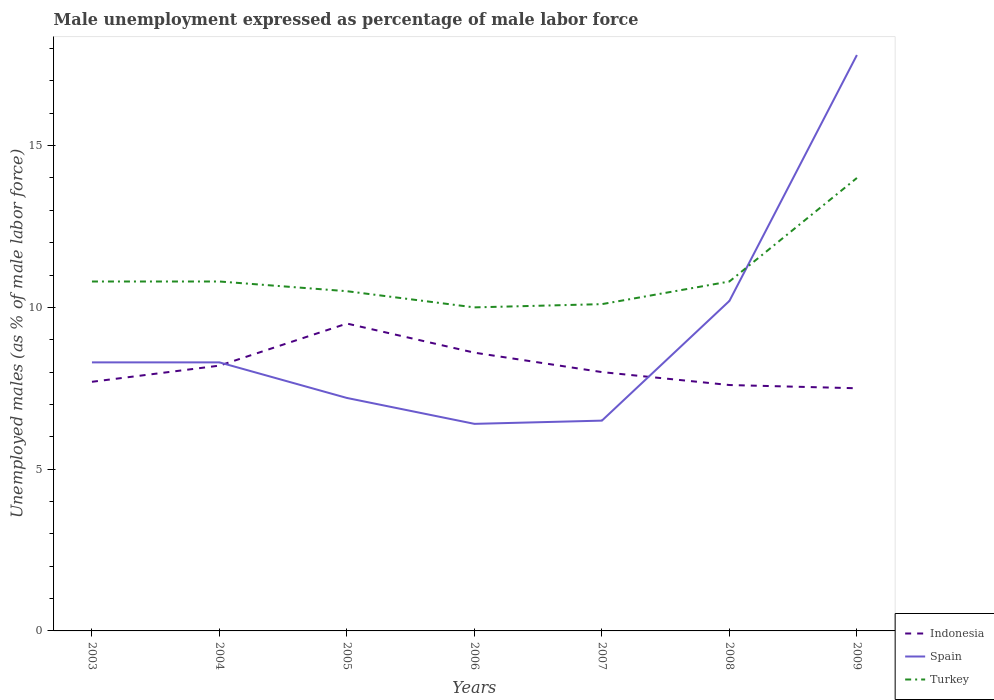How many different coloured lines are there?
Provide a succinct answer. 3. In which year was the unemployment in males in in Turkey maximum?
Keep it short and to the point. 2006. What is the total unemployment in males in in Spain in the graph?
Provide a short and direct response. 1.9. What is the difference between the highest and the lowest unemployment in males in in Spain?
Your answer should be compact. 2. Is the unemployment in males in in Turkey strictly greater than the unemployment in males in in Spain over the years?
Offer a terse response. No. How many lines are there?
Your answer should be compact. 3. What is the title of the graph?
Provide a short and direct response. Male unemployment expressed as percentage of male labor force. Does "Palau" appear as one of the legend labels in the graph?
Give a very brief answer. No. What is the label or title of the X-axis?
Give a very brief answer. Years. What is the label or title of the Y-axis?
Your answer should be very brief. Unemployed males (as % of male labor force). What is the Unemployed males (as % of male labor force) in Indonesia in 2003?
Make the answer very short. 7.7. What is the Unemployed males (as % of male labor force) of Spain in 2003?
Offer a terse response. 8.3. What is the Unemployed males (as % of male labor force) in Turkey in 2003?
Give a very brief answer. 10.8. What is the Unemployed males (as % of male labor force) of Indonesia in 2004?
Provide a short and direct response. 8.2. What is the Unemployed males (as % of male labor force) of Spain in 2004?
Offer a very short reply. 8.3. What is the Unemployed males (as % of male labor force) of Turkey in 2004?
Your answer should be compact. 10.8. What is the Unemployed males (as % of male labor force) in Indonesia in 2005?
Make the answer very short. 9.5. What is the Unemployed males (as % of male labor force) in Spain in 2005?
Give a very brief answer. 7.2. What is the Unemployed males (as % of male labor force) in Turkey in 2005?
Give a very brief answer. 10.5. What is the Unemployed males (as % of male labor force) of Indonesia in 2006?
Your answer should be compact. 8.6. What is the Unemployed males (as % of male labor force) in Spain in 2006?
Provide a succinct answer. 6.4. What is the Unemployed males (as % of male labor force) in Turkey in 2007?
Give a very brief answer. 10.1. What is the Unemployed males (as % of male labor force) in Indonesia in 2008?
Provide a succinct answer. 7.6. What is the Unemployed males (as % of male labor force) of Spain in 2008?
Your answer should be very brief. 10.2. What is the Unemployed males (as % of male labor force) in Turkey in 2008?
Provide a short and direct response. 10.8. What is the Unemployed males (as % of male labor force) in Indonesia in 2009?
Provide a succinct answer. 7.5. What is the Unemployed males (as % of male labor force) of Spain in 2009?
Your response must be concise. 17.8. Across all years, what is the maximum Unemployed males (as % of male labor force) in Indonesia?
Your answer should be very brief. 9.5. Across all years, what is the maximum Unemployed males (as % of male labor force) of Spain?
Give a very brief answer. 17.8. Across all years, what is the minimum Unemployed males (as % of male labor force) of Spain?
Keep it short and to the point. 6.4. What is the total Unemployed males (as % of male labor force) of Indonesia in the graph?
Provide a succinct answer. 57.1. What is the total Unemployed males (as % of male labor force) of Spain in the graph?
Your answer should be very brief. 64.7. What is the difference between the Unemployed males (as % of male labor force) in Spain in 2003 and that in 2004?
Provide a short and direct response. 0. What is the difference between the Unemployed males (as % of male labor force) of Spain in 2003 and that in 2005?
Provide a short and direct response. 1.1. What is the difference between the Unemployed males (as % of male labor force) in Turkey in 2003 and that in 2005?
Offer a very short reply. 0.3. What is the difference between the Unemployed males (as % of male labor force) of Spain in 2003 and that in 2006?
Ensure brevity in your answer.  1.9. What is the difference between the Unemployed males (as % of male labor force) in Turkey in 2003 and that in 2006?
Provide a succinct answer. 0.8. What is the difference between the Unemployed males (as % of male labor force) in Indonesia in 2003 and that in 2007?
Offer a very short reply. -0.3. What is the difference between the Unemployed males (as % of male labor force) of Indonesia in 2003 and that in 2008?
Your response must be concise. 0.1. What is the difference between the Unemployed males (as % of male labor force) of Indonesia in 2003 and that in 2009?
Your answer should be very brief. 0.2. What is the difference between the Unemployed males (as % of male labor force) in Turkey in 2003 and that in 2009?
Provide a succinct answer. -3.2. What is the difference between the Unemployed males (as % of male labor force) of Spain in 2004 and that in 2005?
Offer a terse response. 1.1. What is the difference between the Unemployed males (as % of male labor force) in Turkey in 2004 and that in 2005?
Ensure brevity in your answer.  0.3. What is the difference between the Unemployed males (as % of male labor force) of Spain in 2004 and that in 2006?
Ensure brevity in your answer.  1.9. What is the difference between the Unemployed males (as % of male labor force) in Indonesia in 2004 and that in 2007?
Your answer should be compact. 0.2. What is the difference between the Unemployed males (as % of male labor force) in Turkey in 2004 and that in 2007?
Give a very brief answer. 0.7. What is the difference between the Unemployed males (as % of male labor force) in Indonesia in 2004 and that in 2008?
Your answer should be very brief. 0.6. What is the difference between the Unemployed males (as % of male labor force) in Spain in 2004 and that in 2009?
Give a very brief answer. -9.5. What is the difference between the Unemployed males (as % of male labor force) of Indonesia in 2005 and that in 2006?
Your response must be concise. 0.9. What is the difference between the Unemployed males (as % of male labor force) in Spain in 2005 and that in 2006?
Your response must be concise. 0.8. What is the difference between the Unemployed males (as % of male labor force) in Turkey in 2005 and that in 2006?
Your answer should be compact. 0.5. What is the difference between the Unemployed males (as % of male labor force) in Spain in 2005 and that in 2007?
Provide a short and direct response. 0.7. What is the difference between the Unemployed males (as % of male labor force) of Spain in 2005 and that in 2008?
Your answer should be very brief. -3. What is the difference between the Unemployed males (as % of male labor force) of Turkey in 2005 and that in 2008?
Your response must be concise. -0.3. What is the difference between the Unemployed males (as % of male labor force) in Indonesia in 2005 and that in 2009?
Make the answer very short. 2. What is the difference between the Unemployed males (as % of male labor force) of Turkey in 2005 and that in 2009?
Provide a succinct answer. -3.5. What is the difference between the Unemployed males (as % of male labor force) in Spain in 2006 and that in 2007?
Keep it short and to the point. -0.1. What is the difference between the Unemployed males (as % of male labor force) of Turkey in 2006 and that in 2007?
Offer a very short reply. -0.1. What is the difference between the Unemployed males (as % of male labor force) in Indonesia in 2007 and that in 2008?
Your answer should be very brief. 0.4. What is the difference between the Unemployed males (as % of male labor force) of Spain in 2007 and that in 2008?
Offer a terse response. -3.7. What is the difference between the Unemployed males (as % of male labor force) in Indonesia in 2007 and that in 2009?
Ensure brevity in your answer.  0.5. What is the difference between the Unemployed males (as % of male labor force) of Spain in 2007 and that in 2009?
Your answer should be very brief. -11.3. What is the difference between the Unemployed males (as % of male labor force) in Turkey in 2007 and that in 2009?
Make the answer very short. -3.9. What is the difference between the Unemployed males (as % of male labor force) in Indonesia in 2008 and that in 2009?
Your response must be concise. 0.1. What is the difference between the Unemployed males (as % of male labor force) in Turkey in 2008 and that in 2009?
Give a very brief answer. -3.2. What is the difference between the Unemployed males (as % of male labor force) in Indonesia in 2003 and the Unemployed males (as % of male labor force) in Turkey in 2004?
Offer a terse response. -3.1. What is the difference between the Unemployed males (as % of male labor force) in Spain in 2003 and the Unemployed males (as % of male labor force) in Turkey in 2004?
Give a very brief answer. -2.5. What is the difference between the Unemployed males (as % of male labor force) of Indonesia in 2003 and the Unemployed males (as % of male labor force) of Spain in 2005?
Your answer should be very brief. 0.5. What is the difference between the Unemployed males (as % of male labor force) in Indonesia in 2003 and the Unemployed males (as % of male labor force) in Turkey in 2005?
Provide a short and direct response. -2.8. What is the difference between the Unemployed males (as % of male labor force) of Indonesia in 2003 and the Unemployed males (as % of male labor force) of Spain in 2006?
Offer a very short reply. 1.3. What is the difference between the Unemployed males (as % of male labor force) in Indonesia in 2003 and the Unemployed males (as % of male labor force) in Spain in 2007?
Offer a very short reply. 1.2. What is the difference between the Unemployed males (as % of male labor force) in Indonesia in 2003 and the Unemployed males (as % of male labor force) in Spain in 2008?
Offer a very short reply. -2.5. What is the difference between the Unemployed males (as % of male labor force) in Indonesia in 2003 and the Unemployed males (as % of male labor force) in Spain in 2009?
Your response must be concise. -10.1. What is the difference between the Unemployed males (as % of male labor force) of Indonesia in 2003 and the Unemployed males (as % of male labor force) of Turkey in 2009?
Provide a succinct answer. -6.3. What is the difference between the Unemployed males (as % of male labor force) of Indonesia in 2004 and the Unemployed males (as % of male labor force) of Spain in 2005?
Give a very brief answer. 1. What is the difference between the Unemployed males (as % of male labor force) in Indonesia in 2004 and the Unemployed males (as % of male labor force) in Turkey in 2005?
Provide a succinct answer. -2.3. What is the difference between the Unemployed males (as % of male labor force) in Indonesia in 2004 and the Unemployed males (as % of male labor force) in Spain in 2006?
Keep it short and to the point. 1.8. What is the difference between the Unemployed males (as % of male labor force) in Indonesia in 2004 and the Unemployed males (as % of male labor force) in Turkey in 2006?
Offer a very short reply. -1.8. What is the difference between the Unemployed males (as % of male labor force) in Spain in 2004 and the Unemployed males (as % of male labor force) in Turkey in 2006?
Your answer should be compact. -1.7. What is the difference between the Unemployed males (as % of male labor force) in Spain in 2005 and the Unemployed males (as % of male labor force) in Turkey in 2006?
Make the answer very short. -2.8. What is the difference between the Unemployed males (as % of male labor force) of Indonesia in 2005 and the Unemployed males (as % of male labor force) of Spain in 2007?
Give a very brief answer. 3. What is the difference between the Unemployed males (as % of male labor force) in Indonesia in 2005 and the Unemployed males (as % of male labor force) in Turkey in 2007?
Provide a short and direct response. -0.6. What is the difference between the Unemployed males (as % of male labor force) of Spain in 2005 and the Unemployed males (as % of male labor force) of Turkey in 2007?
Provide a short and direct response. -2.9. What is the difference between the Unemployed males (as % of male labor force) of Spain in 2005 and the Unemployed males (as % of male labor force) of Turkey in 2008?
Give a very brief answer. -3.6. What is the difference between the Unemployed males (as % of male labor force) of Indonesia in 2005 and the Unemployed males (as % of male labor force) of Spain in 2009?
Offer a very short reply. -8.3. What is the difference between the Unemployed males (as % of male labor force) of Indonesia in 2005 and the Unemployed males (as % of male labor force) of Turkey in 2009?
Ensure brevity in your answer.  -4.5. What is the difference between the Unemployed males (as % of male labor force) in Spain in 2005 and the Unemployed males (as % of male labor force) in Turkey in 2009?
Provide a short and direct response. -6.8. What is the difference between the Unemployed males (as % of male labor force) of Indonesia in 2006 and the Unemployed males (as % of male labor force) of Turkey in 2008?
Your response must be concise. -2.2. What is the difference between the Unemployed males (as % of male labor force) of Spain in 2006 and the Unemployed males (as % of male labor force) of Turkey in 2009?
Your answer should be compact. -7.6. What is the difference between the Unemployed males (as % of male labor force) in Indonesia in 2007 and the Unemployed males (as % of male labor force) in Turkey in 2009?
Give a very brief answer. -6. What is the average Unemployed males (as % of male labor force) of Indonesia per year?
Offer a terse response. 8.16. What is the average Unemployed males (as % of male labor force) of Spain per year?
Ensure brevity in your answer.  9.24. In the year 2003, what is the difference between the Unemployed males (as % of male labor force) of Indonesia and Unemployed males (as % of male labor force) of Spain?
Provide a short and direct response. -0.6. In the year 2003, what is the difference between the Unemployed males (as % of male labor force) of Spain and Unemployed males (as % of male labor force) of Turkey?
Your answer should be compact. -2.5. In the year 2004, what is the difference between the Unemployed males (as % of male labor force) of Indonesia and Unemployed males (as % of male labor force) of Turkey?
Your answer should be compact. -2.6. In the year 2006, what is the difference between the Unemployed males (as % of male labor force) of Indonesia and Unemployed males (as % of male labor force) of Spain?
Offer a terse response. 2.2. In the year 2006, what is the difference between the Unemployed males (as % of male labor force) in Indonesia and Unemployed males (as % of male labor force) in Turkey?
Your answer should be very brief. -1.4. In the year 2006, what is the difference between the Unemployed males (as % of male labor force) in Spain and Unemployed males (as % of male labor force) in Turkey?
Give a very brief answer. -3.6. In the year 2007, what is the difference between the Unemployed males (as % of male labor force) of Indonesia and Unemployed males (as % of male labor force) of Turkey?
Offer a very short reply. -2.1. In the year 2008, what is the difference between the Unemployed males (as % of male labor force) of Indonesia and Unemployed males (as % of male labor force) of Spain?
Offer a terse response. -2.6. In the year 2009, what is the difference between the Unemployed males (as % of male labor force) of Spain and Unemployed males (as % of male labor force) of Turkey?
Ensure brevity in your answer.  3.8. What is the ratio of the Unemployed males (as % of male labor force) of Indonesia in 2003 to that in 2004?
Make the answer very short. 0.94. What is the ratio of the Unemployed males (as % of male labor force) in Spain in 2003 to that in 2004?
Offer a terse response. 1. What is the ratio of the Unemployed males (as % of male labor force) of Indonesia in 2003 to that in 2005?
Your answer should be compact. 0.81. What is the ratio of the Unemployed males (as % of male labor force) of Spain in 2003 to that in 2005?
Provide a short and direct response. 1.15. What is the ratio of the Unemployed males (as % of male labor force) of Turkey in 2003 to that in 2005?
Provide a short and direct response. 1.03. What is the ratio of the Unemployed males (as % of male labor force) in Indonesia in 2003 to that in 2006?
Keep it short and to the point. 0.9. What is the ratio of the Unemployed males (as % of male labor force) in Spain in 2003 to that in 2006?
Offer a terse response. 1.3. What is the ratio of the Unemployed males (as % of male labor force) in Indonesia in 2003 to that in 2007?
Your answer should be very brief. 0.96. What is the ratio of the Unemployed males (as % of male labor force) in Spain in 2003 to that in 2007?
Make the answer very short. 1.28. What is the ratio of the Unemployed males (as % of male labor force) in Turkey in 2003 to that in 2007?
Give a very brief answer. 1.07. What is the ratio of the Unemployed males (as % of male labor force) of Indonesia in 2003 to that in 2008?
Offer a very short reply. 1.01. What is the ratio of the Unemployed males (as % of male labor force) in Spain in 2003 to that in 2008?
Give a very brief answer. 0.81. What is the ratio of the Unemployed males (as % of male labor force) of Turkey in 2003 to that in 2008?
Provide a short and direct response. 1. What is the ratio of the Unemployed males (as % of male labor force) in Indonesia in 2003 to that in 2009?
Offer a very short reply. 1.03. What is the ratio of the Unemployed males (as % of male labor force) in Spain in 2003 to that in 2009?
Keep it short and to the point. 0.47. What is the ratio of the Unemployed males (as % of male labor force) in Turkey in 2003 to that in 2009?
Make the answer very short. 0.77. What is the ratio of the Unemployed males (as % of male labor force) in Indonesia in 2004 to that in 2005?
Your answer should be very brief. 0.86. What is the ratio of the Unemployed males (as % of male labor force) in Spain in 2004 to that in 2005?
Your answer should be very brief. 1.15. What is the ratio of the Unemployed males (as % of male labor force) of Turkey in 2004 to that in 2005?
Your response must be concise. 1.03. What is the ratio of the Unemployed males (as % of male labor force) of Indonesia in 2004 to that in 2006?
Keep it short and to the point. 0.95. What is the ratio of the Unemployed males (as % of male labor force) of Spain in 2004 to that in 2006?
Provide a short and direct response. 1.3. What is the ratio of the Unemployed males (as % of male labor force) of Turkey in 2004 to that in 2006?
Your response must be concise. 1.08. What is the ratio of the Unemployed males (as % of male labor force) in Spain in 2004 to that in 2007?
Provide a succinct answer. 1.28. What is the ratio of the Unemployed males (as % of male labor force) of Turkey in 2004 to that in 2007?
Your answer should be compact. 1.07. What is the ratio of the Unemployed males (as % of male labor force) of Indonesia in 2004 to that in 2008?
Your answer should be compact. 1.08. What is the ratio of the Unemployed males (as % of male labor force) of Spain in 2004 to that in 2008?
Your answer should be compact. 0.81. What is the ratio of the Unemployed males (as % of male labor force) of Turkey in 2004 to that in 2008?
Your answer should be compact. 1. What is the ratio of the Unemployed males (as % of male labor force) of Indonesia in 2004 to that in 2009?
Your response must be concise. 1.09. What is the ratio of the Unemployed males (as % of male labor force) in Spain in 2004 to that in 2009?
Provide a succinct answer. 0.47. What is the ratio of the Unemployed males (as % of male labor force) of Turkey in 2004 to that in 2009?
Offer a very short reply. 0.77. What is the ratio of the Unemployed males (as % of male labor force) in Indonesia in 2005 to that in 2006?
Offer a very short reply. 1.1. What is the ratio of the Unemployed males (as % of male labor force) in Spain in 2005 to that in 2006?
Your response must be concise. 1.12. What is the ratio of the Unemployed males (as % of male labor force) of Turkey in 2005 to that in 2006?
Offer a terse response. 1.05. What is the ratio of the Unemployed males (as % of male labor force) of Indonesia in 2005 to that in 2007?
Keep it short and to the point. 1.19. What is the ratio of the Unemployed males (as % of male labor force) of Spain in 2005 to that in 2007?
Make the answer very short. 1.11. What is the ratio of the Unemployed males (as % of male labor force) in Turkey in 2005 to that in 2007?
Offer a terse response. 1.04. What is the ratio of the Unemployed males (as % of male labor force) of Indonesia in 2005 to that in 2008?
Offer a very short reply. 1.25. What is the ratio of the Unemployed males (as % of male labor force) of Spain in 2005 to that in 2008?
Ensure brevity in your answer.  0.71. What is the ratio of the Unemployed males (as % of male labor force) in Turkey in 2005 to that in 2008?
Offer a very short reply. 0.97. What is the ratio of the Unemployed males (as % of male labor force) of Indonesia in 2005 to that in 2009?
Provide a succinct answer. 1.27. What is the ratio of the Unemployed males (as % of male labor force) of Spain in 2005 to that in 2009?
Make the answer very short. 0.4. What is the ratio of the Unemployed males (as % of male labor force) of Turkey in 2005 to that in 2009?
Your answer should be compact. 0.75. What is the ratio of the Unemployed males (as % of male labor force) of Indonesia in 2006 to that in 2007?
Keep it short and to the point. 1.07. What is the ratio of the Unemployed males (as % of male labor force) of Spain in 2006 to that in 2007?
Provide a succinct answer. 0.98. What is the ratio of the Unemployed males (as % of male labor force) of Turkey in 2006 to that in 2007?
Provide a short and direct response. 0.99. What is the ratio of the Unemployed males (as % of male labor force) in Indonesia in 2006 to that in 2008?
Your answer should be compact. 1.13. What is the ratio of the Unemployed males (as % of male labor force) in Spain in 2006 to that in 2008?
Provide a succinct answer. 0.63. What is the ratio of the Unemployed males (as % of male labor force) of Turkey in 2006 to that in 2008?
Your answer should be compact. 0.93. What is the ratio of the Unemployed males (as % of male labor force) of Indonesia in 2006 to that in 2009?
Make the answer very short. 1.15. What is the ratio of the Unemployed males (as % of male labor force) in Spain in 2006 to that in 2009?
Make the answer very short. 0.36. What is the ratio of the Unemployed males (as % of male labor force) of Turkey in 2006 to that in 2009?
Provide a short and direct response. 0.71. What is the ratio of the Unemployed males (as % of male labor force) in Indonesia in 2007 to that in 2008?
Give a very brief answer. 1.05. What is the ratio of the Unemployed males (as % of male labor force) in Spain in 2007 to that in 2008?
Your answer should be compact. 0.64. What is the ratio of the Unemployed males (as % of male labor force) of Turkey in 2007 to that in 2008?
Your response must be concise. 0.94. What is the ratio of the Unemployed males (as % of male labor force) of Indonesia in 2007 to that in 2009?
Provide a succinct answer. 1.07. What is the ratio of the Unemployed males (as % of male labor force) in Spain in 2007 to that in 2009?
Provide a succinct answer. 0.37. What is the ratio of the Unemployed males (as % of male labor force) of Turkey in 2007 to that in 2009?
Offer a terse response. 0.72. What is the ratio of the Unemployed males (as % of male labor force) of Indonesia in 2008 to that in 2009?
Offer a terse response. 1.01. What is the ratio of the Unemployed males (as % of male labor force) of Spain in 2008 to that in 2009?
Ensure brevity in your answer.  0.57. What is the ratio of the Unemployed males (as % of male labor force) of Turkey in 2008 to that in 2009?
Your answer should be compact. 0.77. What is the difference between the highest and the second highest Unemployed males (as % of male labor force) of Spain?
Offer a very short reply. 7.6. What is the difference between the highest and the lowest Unemployed males (as % of male labor force) of Indonesia?
Provide a short and direct response. 2. What is the difference between the highest and the lowest Unemployed males (as % of male labor force) of Spain?
Offer a very short reply. 11.4. 